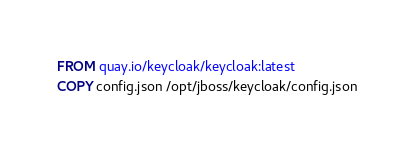Convert code to text. <code><loc_0><loc_0><loc_500><loc_500><_Dockerfile_>FROM quay.io/keycloak/keycloak:latest
COPY config.json /opt/jboss/keycloak/config.json
</code> 